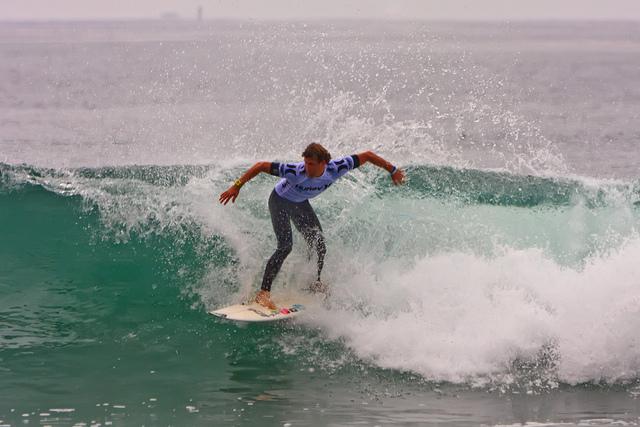What color shirt is the person wearing?
Answer briefly. Blue. Is the woman catching a wave?
Write a very short answer. Yes. Would you feel comfortable surfing here?
Give a very brief answer. Yes. Would you be excited to do this?
Write a very short answer. No. Is the water under the surfboard clear?
Short answer required. Yes. Is this man skiing?
Concise answer only. No. 